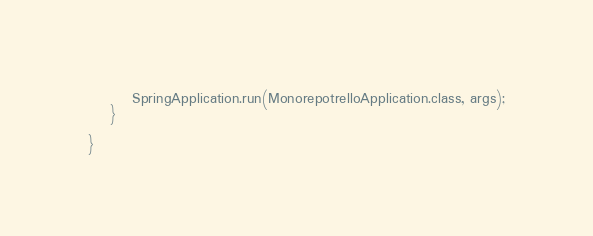Convert code to text. <code><loc_0><loc_0><loc_500><loc_500><_Java_>		SpringApplication.run(MonorepotrelloApplication.class, args);
	}

}
</code> 